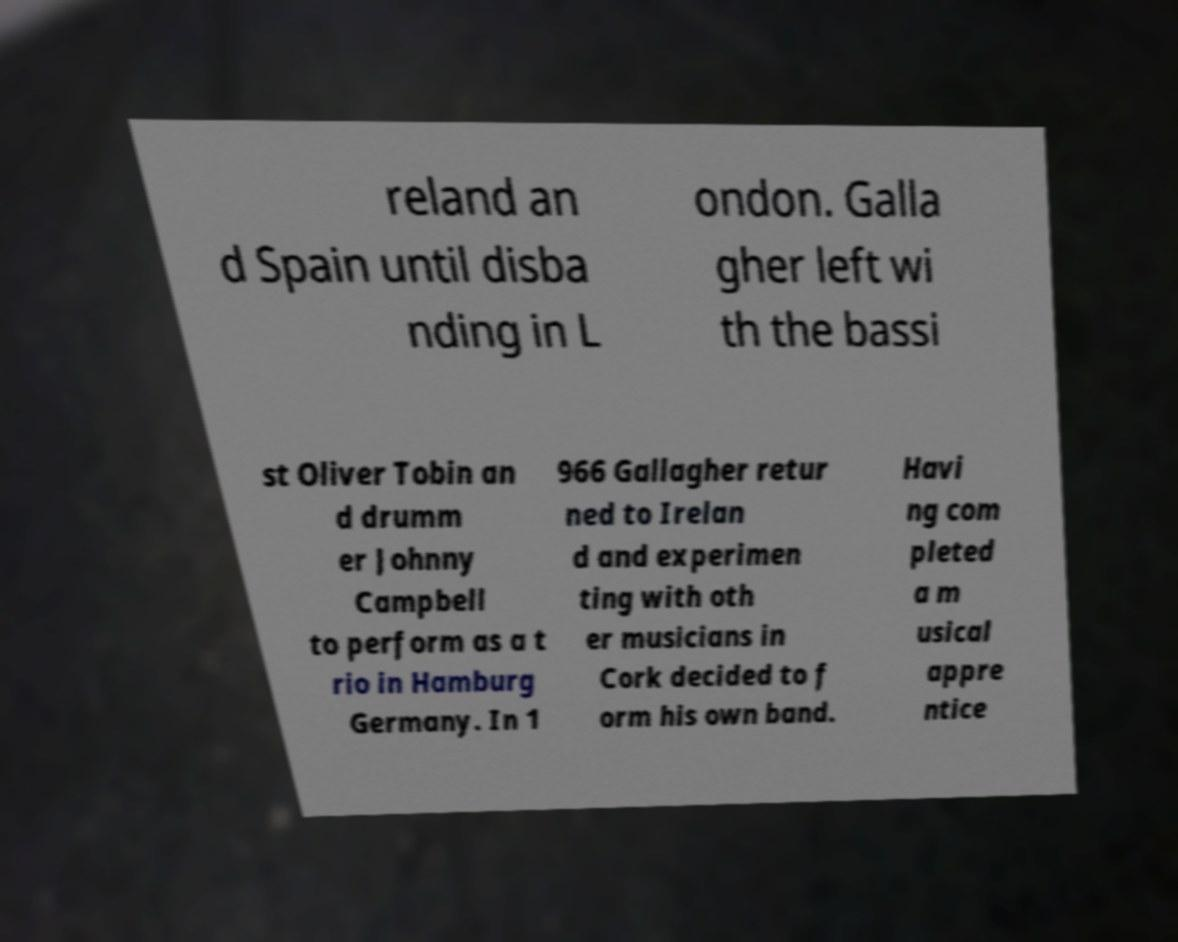Could you extract and type out the text from this image? reland an d Spain until disba nding in L ondon. Galla gher left wi th the bassi st Oliver Tobin an d drumm er Johnny Campbell to perform as a t rio in Hamburg Germany. In 1 966 Gallagher retur ned to Irelan d and experimen ting with oth er musicians in Cork decided to f orm his own band. Havi ng com pleted a m usical appre ntice 